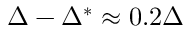Convert formula to latex. <formula><loc_0><loc_0><loc_500><loc_500>\Delta - \Delta ^ { * } \approx 0 . 2 \Delta</formula> 